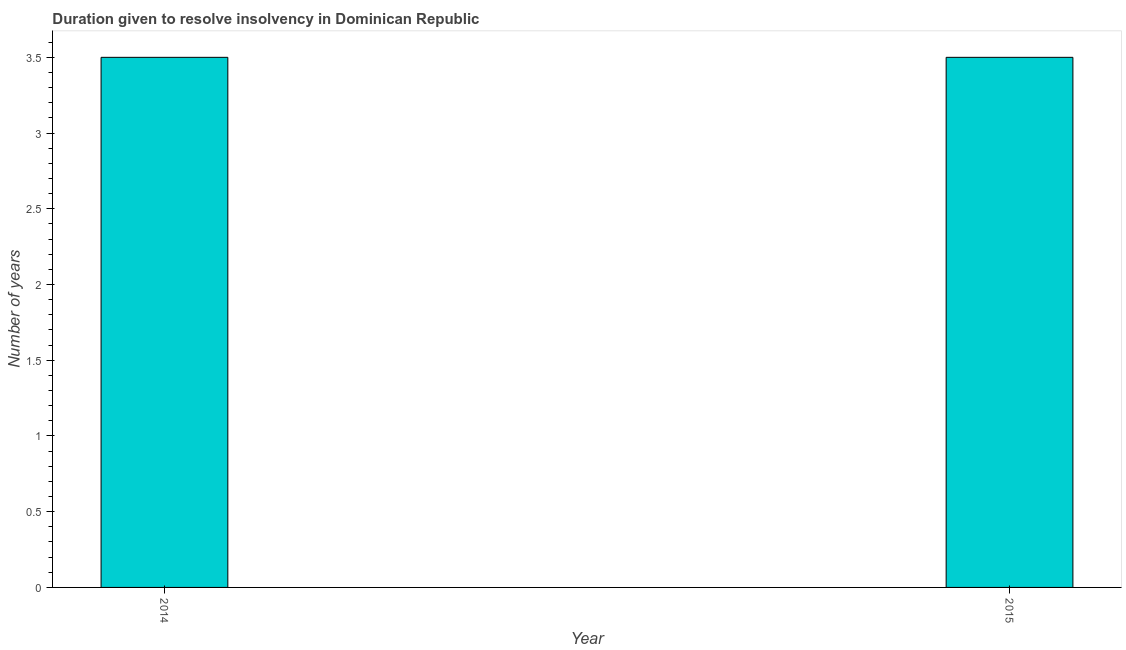Does the graph contain any zero values?
Your response must be concise. No. What is the title of the graph?
Keep it short and to the point. Duration given to resolve insolvency in Dominican Republic. What is the label or title of the X-axis?
Your response must be concise. Year. What is the label or title of the Y-axis?
Your answer should be compact. Number of years. Across all years, what is the maximum number of years to resolve insolvency?
Provide a short and direct response. 3.5. In which year was the number of years to resolve insolvency minimum?
Offer a terse response. 2014. What is the sum of the number of years to resolve insolvency?
Ensure brevity in your answer.  7. What is the difference between the number of years to resolve insolvency in 2014 and 2015?
Keep it short and to the point. 0. What is the ratio of the number of years to resolve insolvency in 2014 to that in 2015?
Make the answer very short. 1. How many years are there in the graph?
Provide a short and direct response. 2. What is the difference between two consecutive major ticks on the Y-axis?
Offer a terse response. 0.5. What is the Number of years in 2014?
Your answer should be very brief. 3.5. What is the difference between the Number of years in 2014 and 2015?
Your response must be concise. 0. 